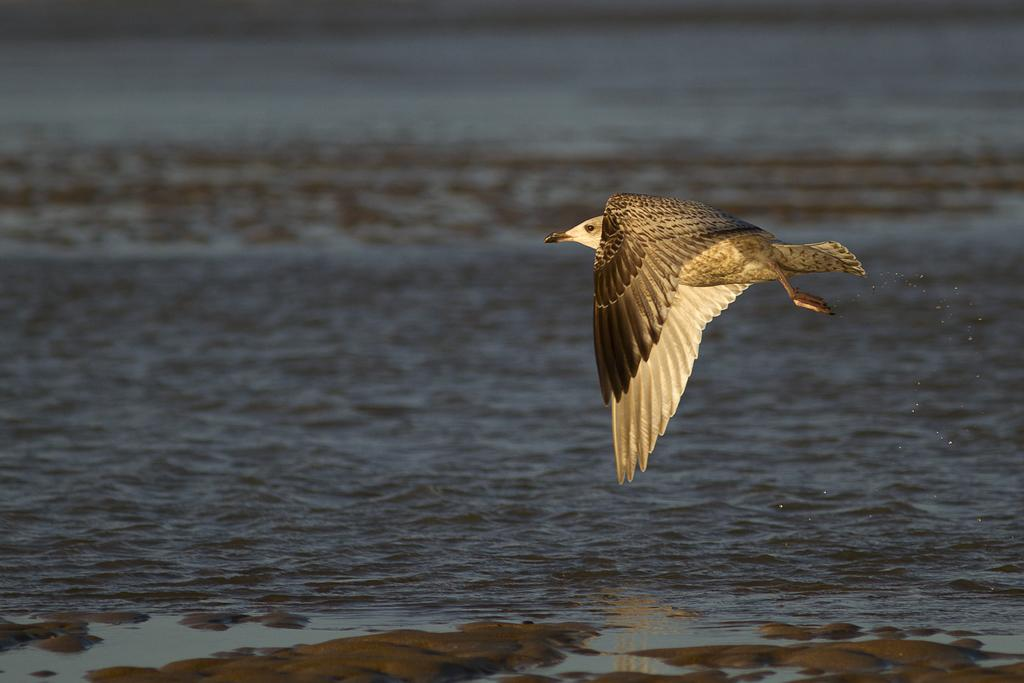What is the main subject of the image? There is a bird flying in the air in the image. What can be seen in the background of the image? There is water visible in the background of the image. Where is the faucet located in the image? There is no faucet present in the image. What color is the balloon that the bird is holding in the image? There is no balloon present in the image, and the bird is not holding anything. 